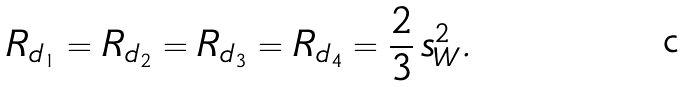<formula> <loc_0><loc_0><loc_500><loc_500>R _ { d _ { 1 } } = R _ { d _ { 2 } } = R _ { d _ { 3 } } = R _ { d _ { 4 } } = \frac { 2 } { 3 } \, s ^ { 2 } _ { W } .</formula> 